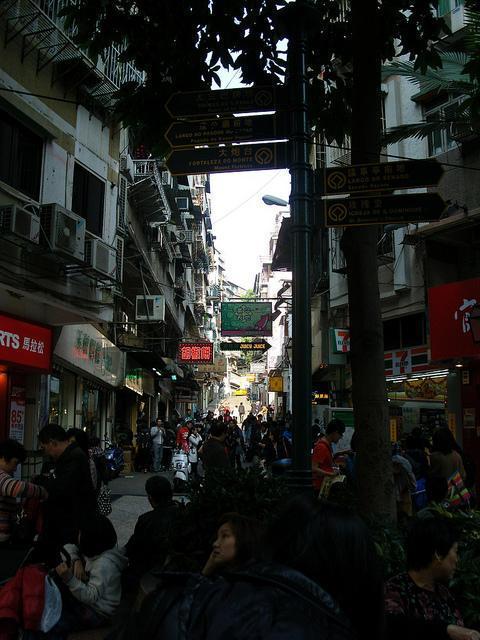How many people are there?
Give a very brief answer. 6. 